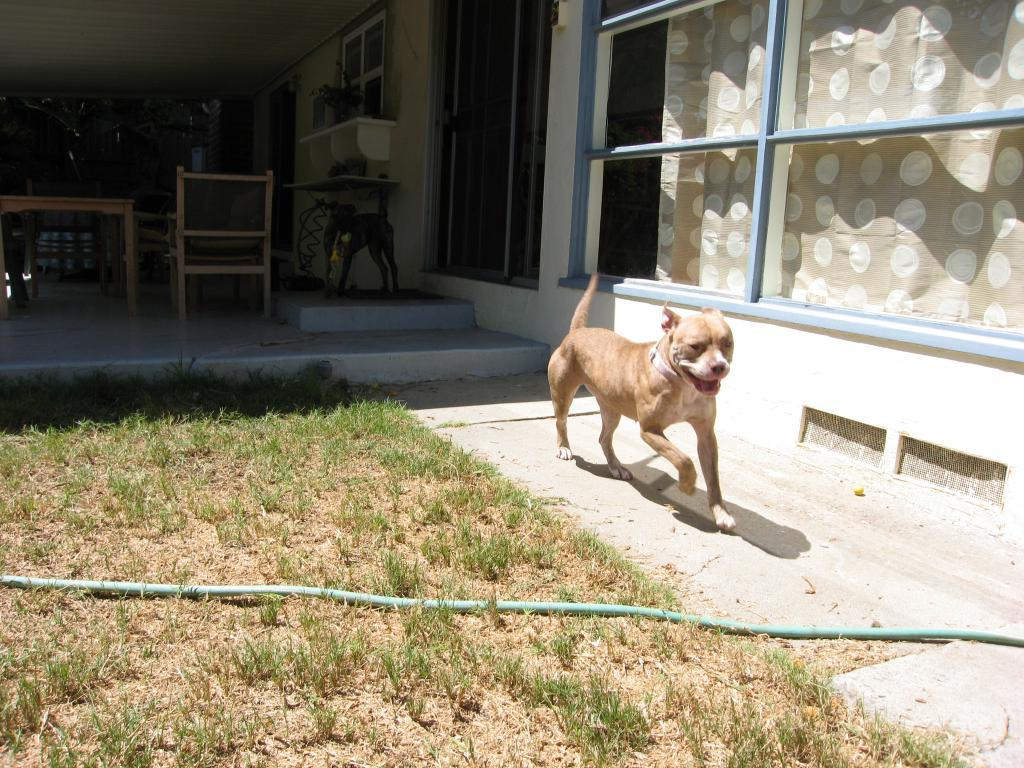What animal can be seen in the image? There is a dog in the image. What is the dog doing in the image? The dog is running on the right side of the image. What is in front of the dog? There is a pipe in front of the dog. What is located on the right side of the image? There is a window on the right side of the image, and it has curtains associated with it. What furniture is visible behind the dog? There is a table behind the dog. What type of seating is near the table? There are chairs near the table. Who is the band's manager in the image? There is no band or manager present in the image; it features a dog running with a pipe in front of it. 